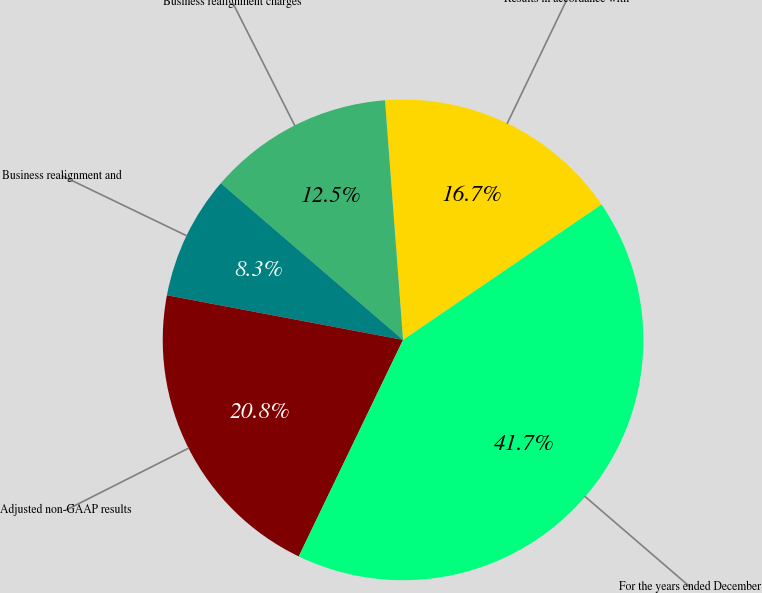<chart> <loc_0><loc_0><loc_500><loc_500><pie_chart><fcel>Results in accordance with<fcel>Business realignment charges<fcel>Business realignment and<fcel>Adjusted non-GAAP results<fcel>For the years ended December<nl><fcel>16.67%<fcel>12.5%<fcel>8.33%<fcel>20.83%<fcel>41.67%<nl></chart> 